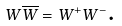Convert formula to latex. <formula><loc_0><loc_0><loc_500><loc_500>W \overline { W } = W ^ { + } W ^ { - } \text {.}</formula> 